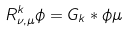<formula> <loc_0><loc_0><loc_500><loc_500>R ^ { k } _ { \nu , \mu } \phi = G _ { k } * \phi \mu</formula> 